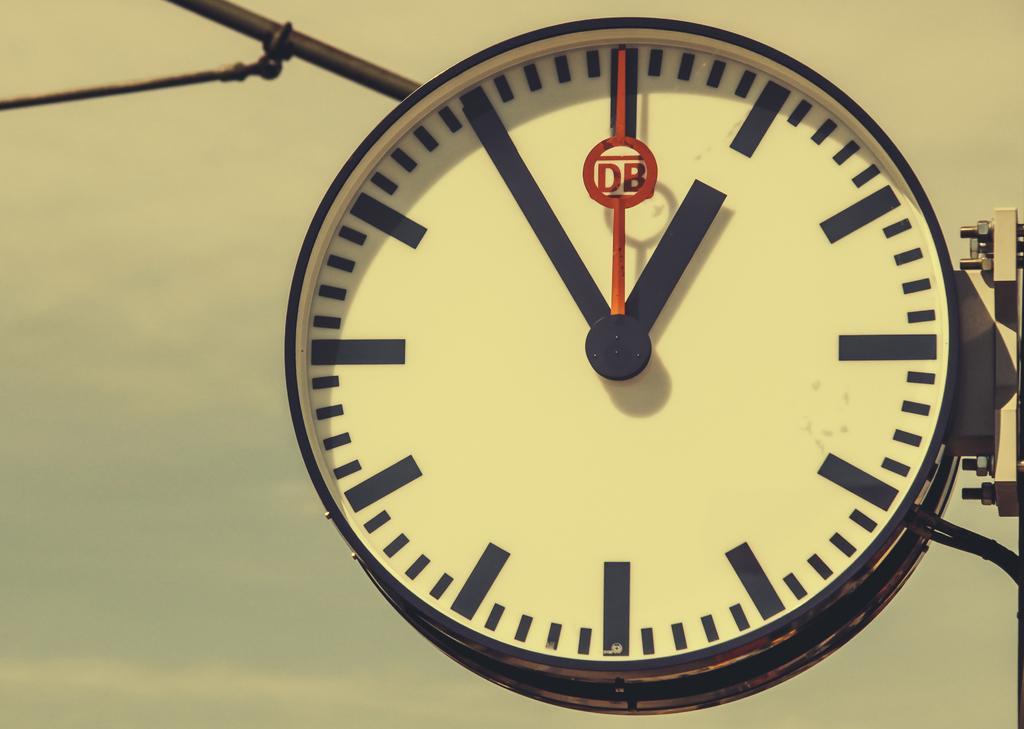Please provide a concise description of this image. In this image we can see a clock and a stand. In the background of the image, we can see the sky. 